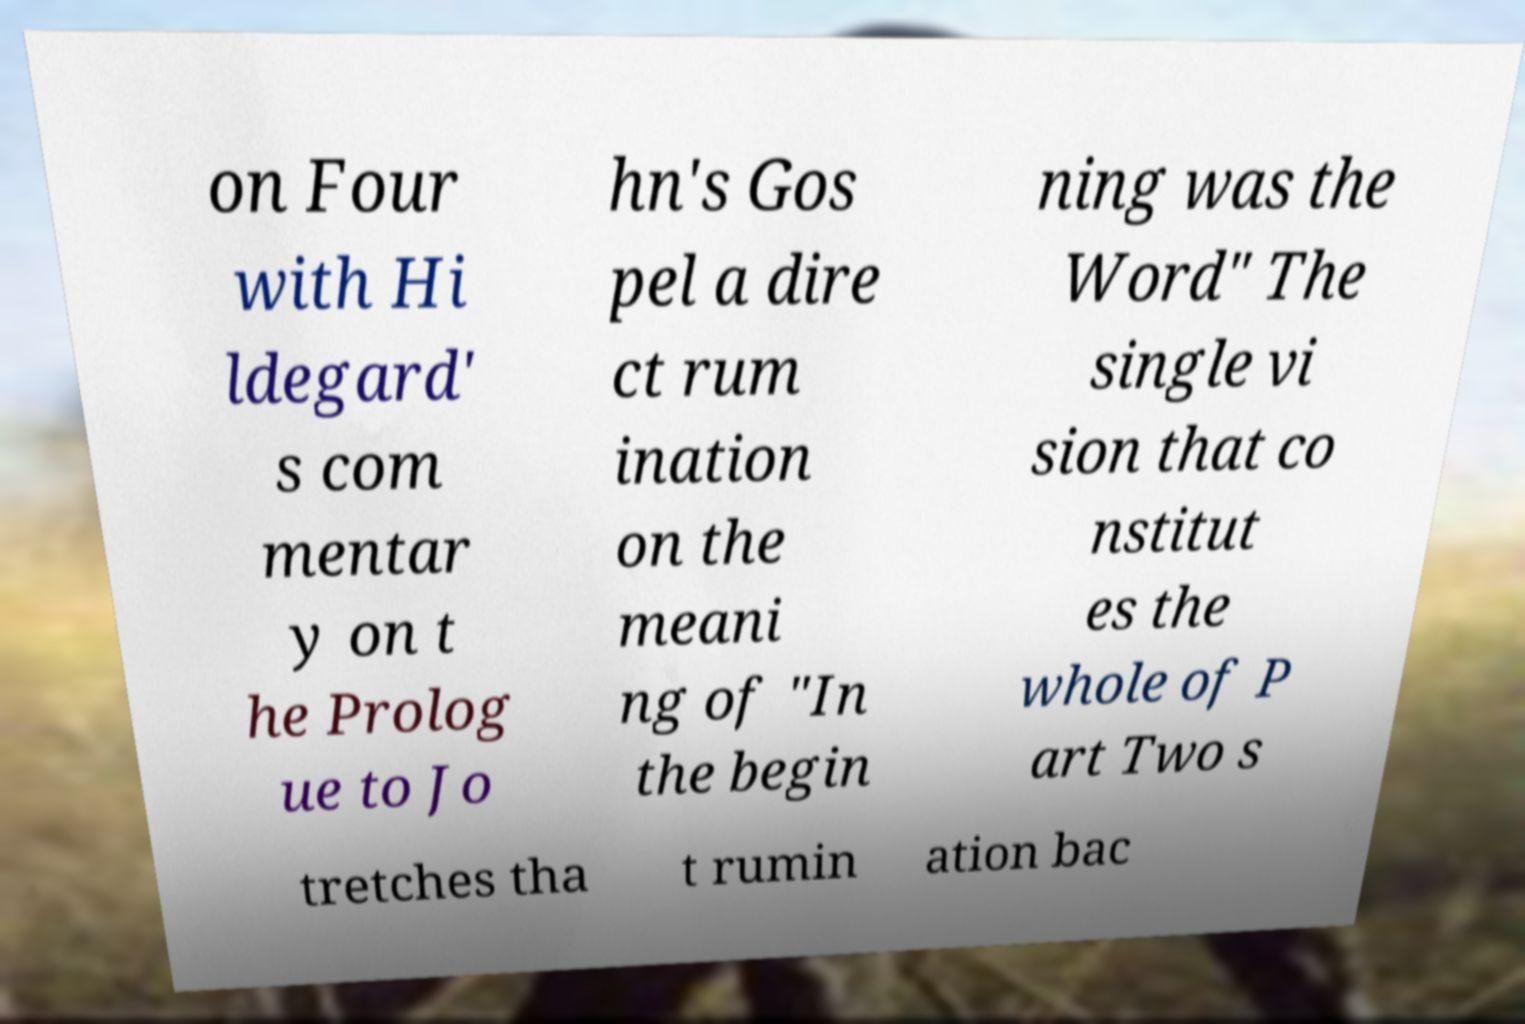Can you accurately transcribe the text from the provided image for me? on Four with Hi ldegard' s com mentar y on t he Prolog ue to Jo hn's Gos pel a dire ct rum ination on the meani ng of "In the begin ning was the Word" The single vi sion that co nstitut es the whole of P art Two s tretches tha t rumin ation bac 